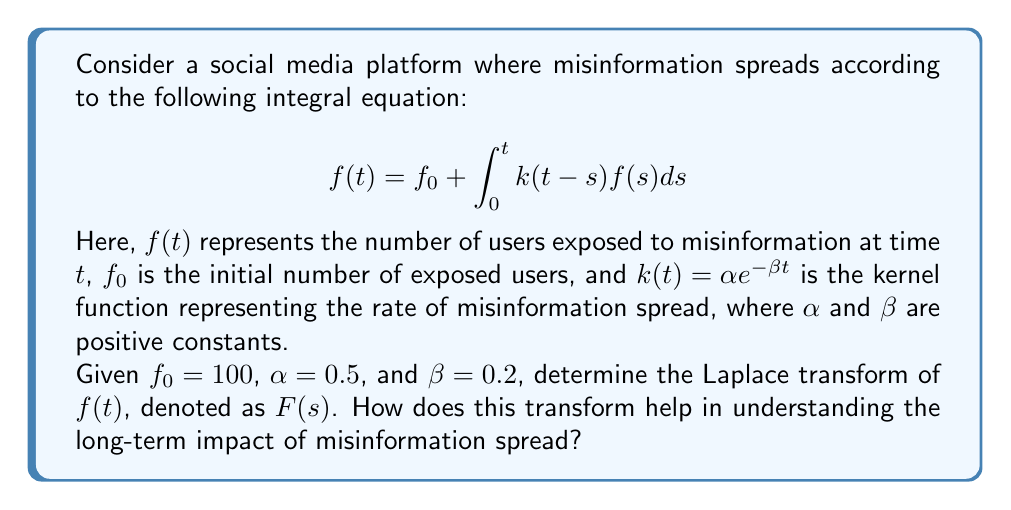Help me with this question. To solve this integral equation and find the Laplace transform of $f(t)$, we'll follow these steps:

1) First, let's take the Laplace transform of both sides of the equation:
   $$\mathcal{L}\{f(t)\} = \mathcal{L}\{f_0\} + \mathcal{L}\{\int_0^t k(t-s)f(s)ds\}$$

2) Using Laplace transform properties:
   - $\mathcal{L}\{f(t)\} = F(s)$
   - $\mathcal{L}\{f_0\} = \frac{f_0}{s}$
   - The Laplace transform of the convolution integral is the product of the Laplace transforms of the functions.

3) Therefore, we have:
   $$F(s) = \frac{f_0}{s} + K(s)F(s)$$
   where $K(s)$ is the Laplace transform of $k(t)$.

4) Calculate $K(s)$:
   $$K(s) = \mathcal{L}\{\alpha e^{-\beta t}\} = \frac{\alpha}{s + \beta}$$

5) Substituting this back into our equation:
   $$F(s) = \frac{f_0}{s} + \frac{\alpha}{s + \beta}F(s)$$

6) Solve for $F(s)$:
   $$F(s)(1 - \frac{\alpha}{s + \beta}) = \frac{f_0}{s}$$
   $$F(s) = \frac{f_0}{s} \cdot \frac{s + \beta}{s + \beta - \alpha}$$

7) Substituting the given values $f_0 = 100$, $\alpha = 0.5$, and $\beta = 0.2$:
   $$F(s) = \frac{100}{s} \cdot \frac{s + 0.2}{s + 0.2 - 0.5} = \frac{100(s + 0.2)}{s(s - 0.3)}$$

The Laplace transform $F(s)$ helps understand the long-term impact of misinformation spread:
- The pole at $s = 0.3$ indicates exponential growth in the time domain.
- As $t \to \infty$, $f(t)$ will grow exponentially, suggesting uncontrolled spread of misinformation.
- The rate of this exponential growth is determined by the positive pole, 0.3 in this case.

This mathematical model highlights the potential dangers of unchecked misinformation in social media, aligning with conservative concerns about the negative impacts of technology on society.
Answer: $F(s) = \frac{100(s + 0.2)}{s(s - 0.3)}$ 